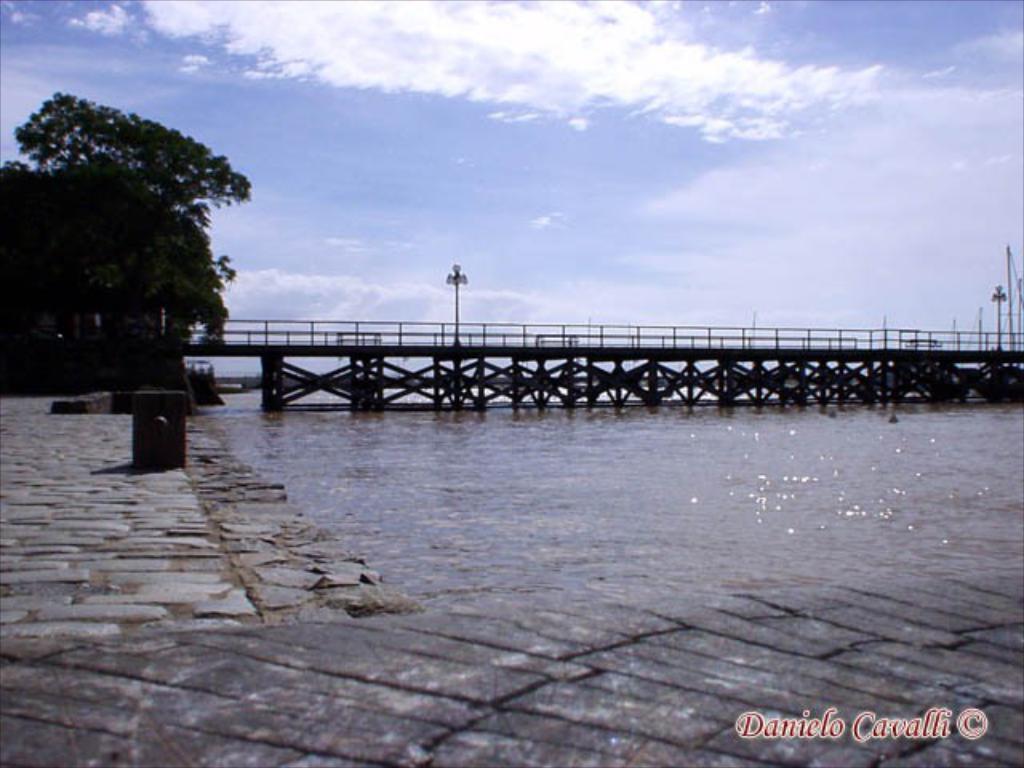Could you give a brief overview of what you see in this image? In this image we can see a bridge, there is a pole, there is a tree, there is the water, the sky is cloudy. 